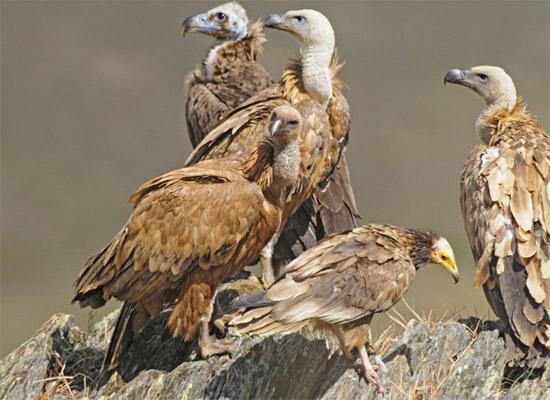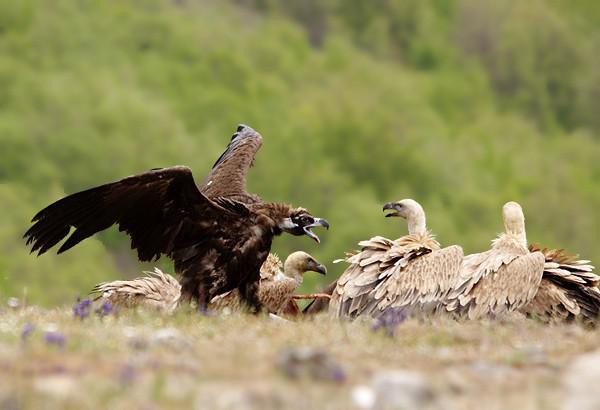The first image is the image on the left, the second image is the image on the right. Evaluate the accuracy of this statement regarding the images: "A vulture has its wings spread, as it confronts another vulture". Is it true? Answer yes or no. Yes. The first image is the image on the left, the second image is the image on the right. For the images shown, is this caption "The left image shows one foreground vulture, which stands on a carcass with its head facing right." true? Answer yes or no. No. 